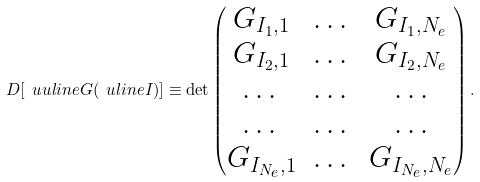Convert formula to latex. <formula><loc_0><loc_0><loc_500><loc_500>D [ { \ u u l i n e G } ( \ u l i n e I ) ] \equiv \det \begin{pmatrix} G _ { I _ { 1 } , 1 } & \dots & G _ { I _ { 1 } , N _ { e } } \\ G _ { I _ { 2 } , 1 } & \dots & G _ { I _ { 2 } , N _ { e } } \\ \dots & \dots & \dots \\ \dots & \dots & \dots \\ G _ { I _ { N _ { e } } , 1 } & \dots & G _ { I _ { N _ { e } } , N _ { e } } \\ \end{pmatrix} .</formula> 